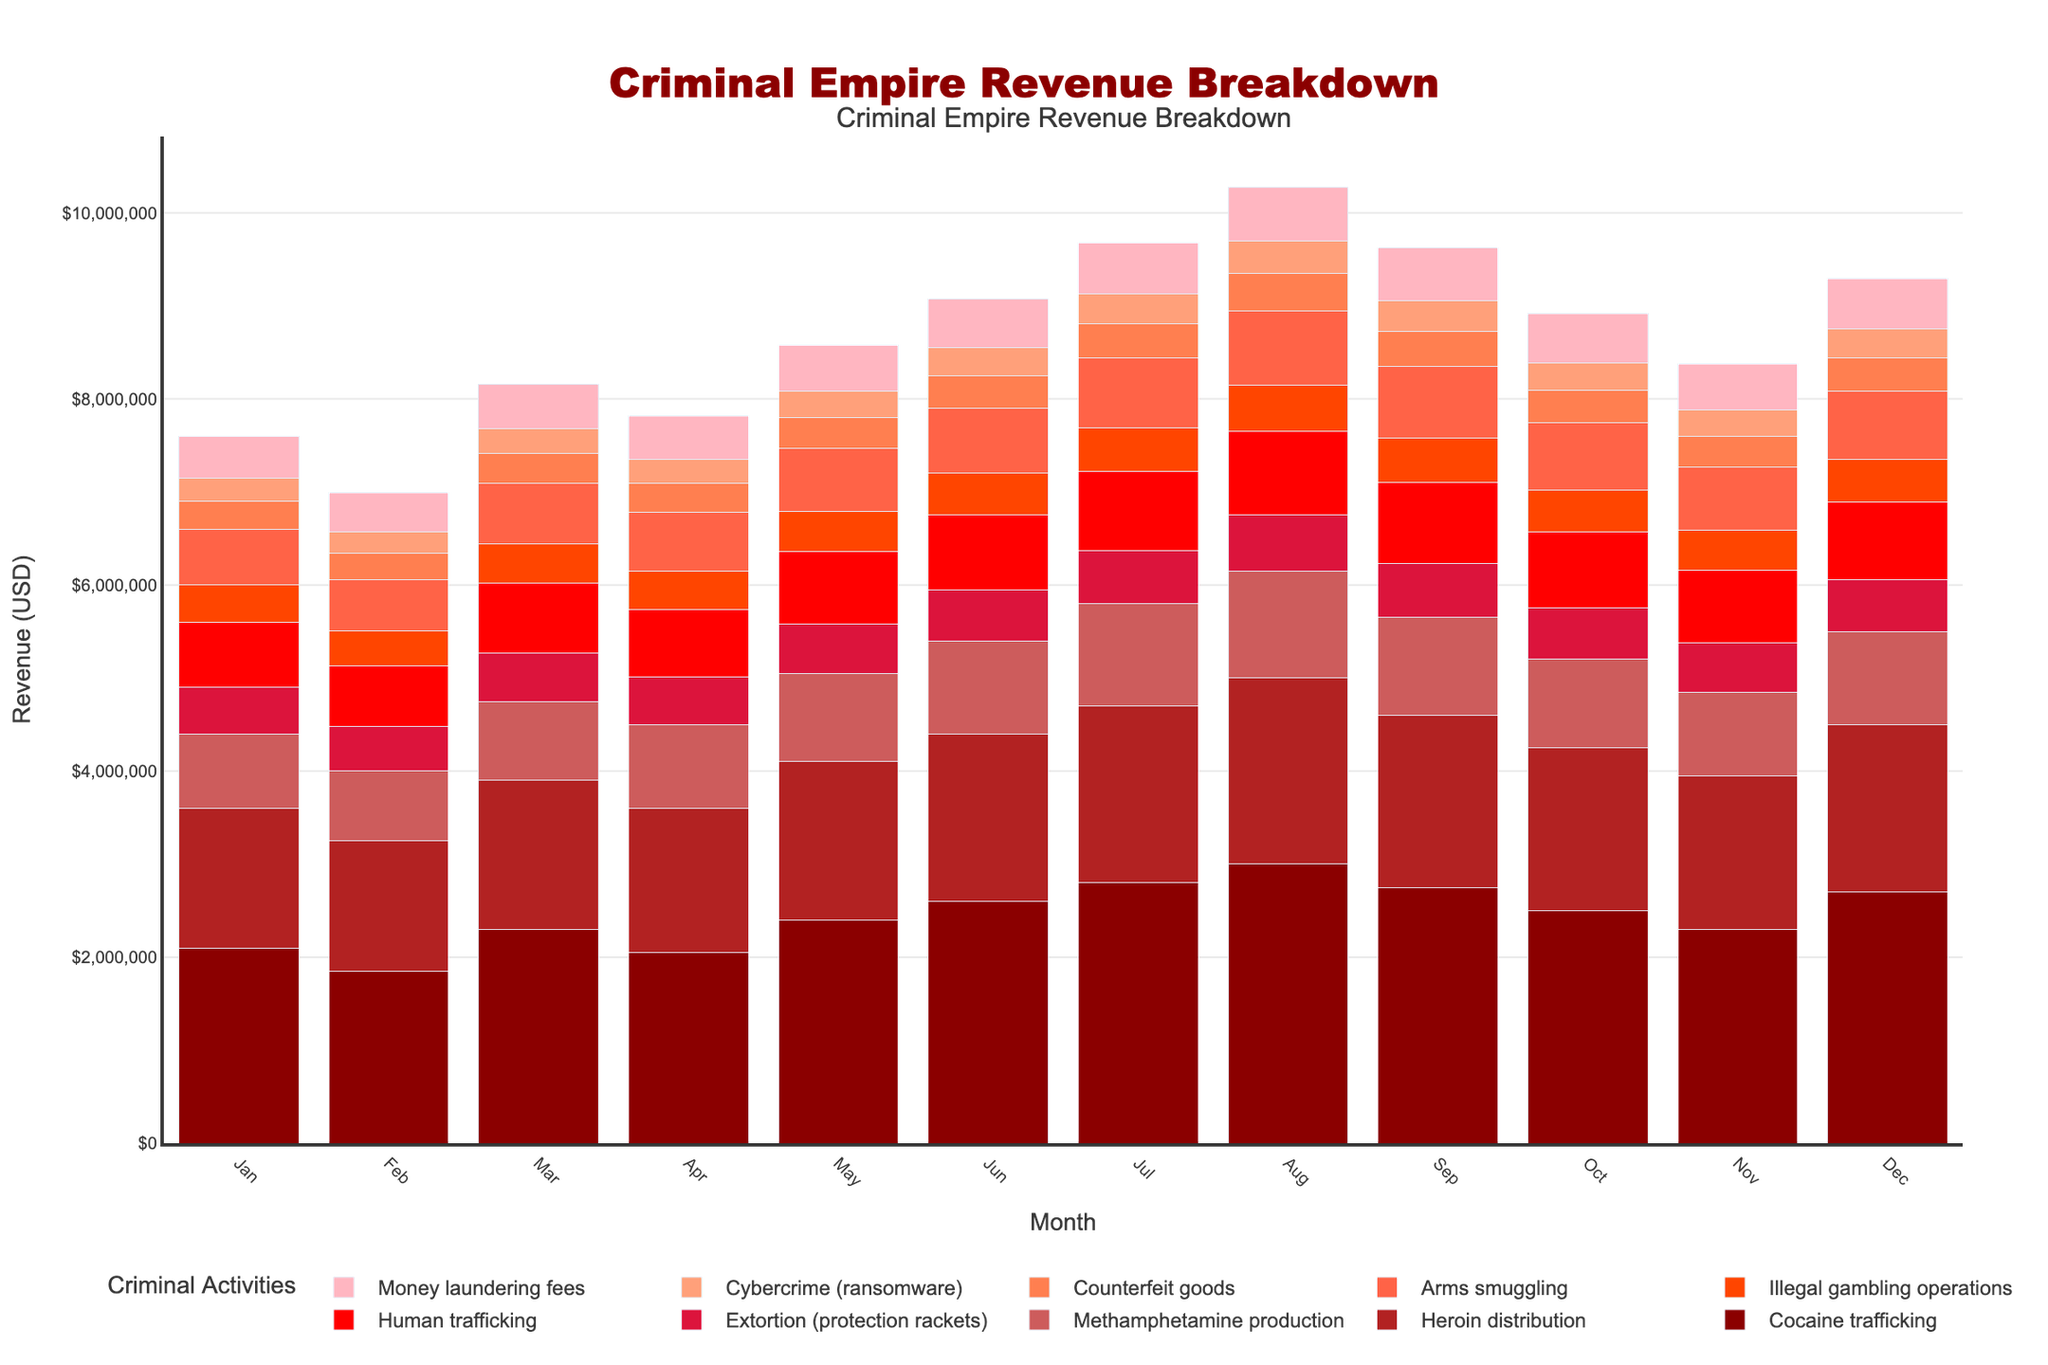Which activity generated the highest revenue in December? The activity with the tallest bar in December is the one with the highest revenue. The highest bar in December belongs to Cocaine trafficking.
Answer: Cocaine trafficking Which activities had revenues higher in July than in June? Compare the height of the bars for July and June for each activity. Cocaine trafficking, Methamphetamine production, Human trafficking, Illegal gambling operations and Arms smuggling show higher bars in July than in June.
Answer: Cocaine trafficking, Methamphetamine production, Human trafficking, Illegal gambling operations, Arms smuggling What is the total revenue from Heroin distribution in the first quarter (Jan-Mar)? Sum the heights of the bars for Heroin distribution in January, February, and March. The revenues are 1,500,000 + 1,400,000 + 1,600,000 = 4,500,000.
Answer: $4,500,000 How does the revenue from Drug activities (Cocaine trafficking, Heroin distribution, Methamphetamine production) in March compare to June? Sum the values for Cocaine trafficking, Heroin distribution, and Methamphetamine production for both March and June. For March, it's 2,300,000 + 1,600,000 + 850,000 = 4,750,000. For June, it's 2,600,000 + 1,800,000 + 1,000,000 = 5,400,000.
Answer: March: $4,750,000, June: $5,400,000 What was the revenue trend for Cybercrime (ransomware) over the year? Observe the heights of the bars for Cybercrime across the months. The trend shows an overall increase starting from 250,000 in January to 310,000 in December, with ups and downs.
Answer: Increasing trend Which month saw the highest combined revenue from all activities? Sum the heights of all bars for each month and identify the month with the largest total height. August has the highest combined revenue.
Answer: August What is the difference in revenue between Human trafficking and Arms smuggling in August? Subtract the revenue of Arms smuggling from Human trafficking in August. Human trafficking is 900,000 and Arms smuggling is 800,000, therefore 900,000 - 800,000 = 100,000.
Answer: $100,000 Compare the revenues of Counterfeit goods and Money laundering fees in October. Which is higher? Compare the heights of the bars for Counterfeit goods and Money laundering fees in October. Money laundering fees (530,000) have a higher revenue than Counterfeit goods (350,000).
Answer: Money laundering fees What is the mean monthly revenue for Extortion (protection rackets)? Sum the revenues for Extortion (protection rackets) for each month and divide by the number of months. The sum is 6,490,000. Divide by 12 months to get approximately 540,833.33.
Answer: $540,833.33 Which activities had similar revenues in April? Compare the heights of the bars for each activity in April. Extortion (510,000) and Illegal gambling operations (410,000) have relatively similar revenues when compared to other activities in April.
Answer: Extortion, Illegal gambling operations 